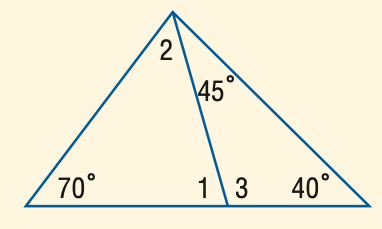Answer the mathemtical geometry problem and directly provide the correct option letter.
Question: Find the measure of \angle 2.
Choices: A: 25 B: 30 C: 35 D: 40 A 